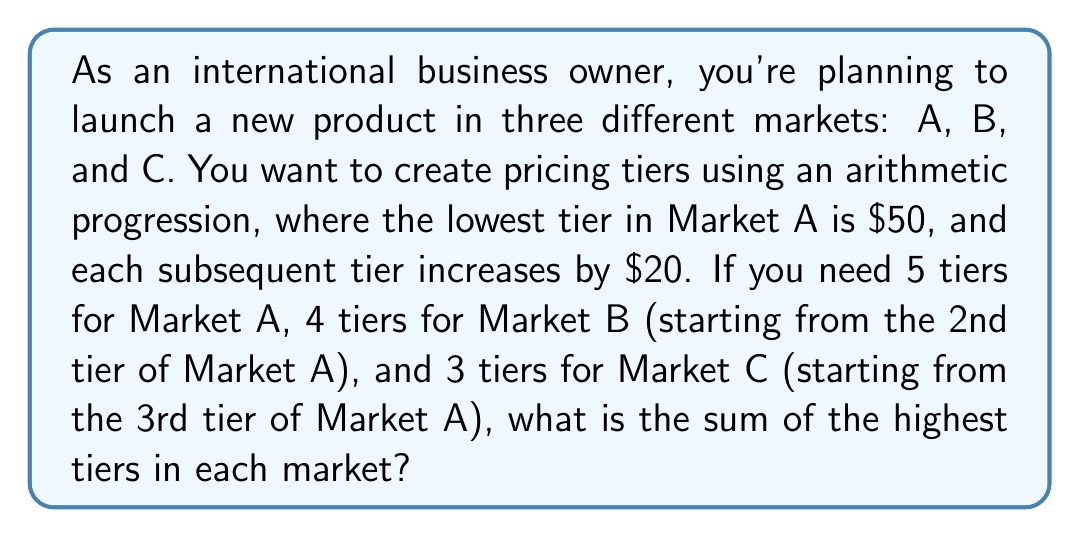Solve this math problem. Let's approach this step-by-step:

1) First, let's establish the arithmetic progression for Market A:
   $a_1 = 50$ (first term)
   $d = 20$ (common difference)
   $n = 5$ (number of terms)

2) The arithmetic progression for Market A is:
   $50, 70, 90, 110, 130$

3) For Market B, we start from the 2nd tier of Market A (70) and have 4 tiers:
   $70, 90, 110, 130$

4) For Market C, we start from the 3rd tier of Market A (90) and have 3 tiers:
   $90, 110, 130$

5) Now, we need to find the highest tier in each market:
   Market A: $130$
   Market B: $130$
   Market C: $130$

6) The sum of the highest tiers is:
   $130 + 130 + 130 = 390$

Therefore, the sum of the highest tiers in each market is $390.
Answer: $390 